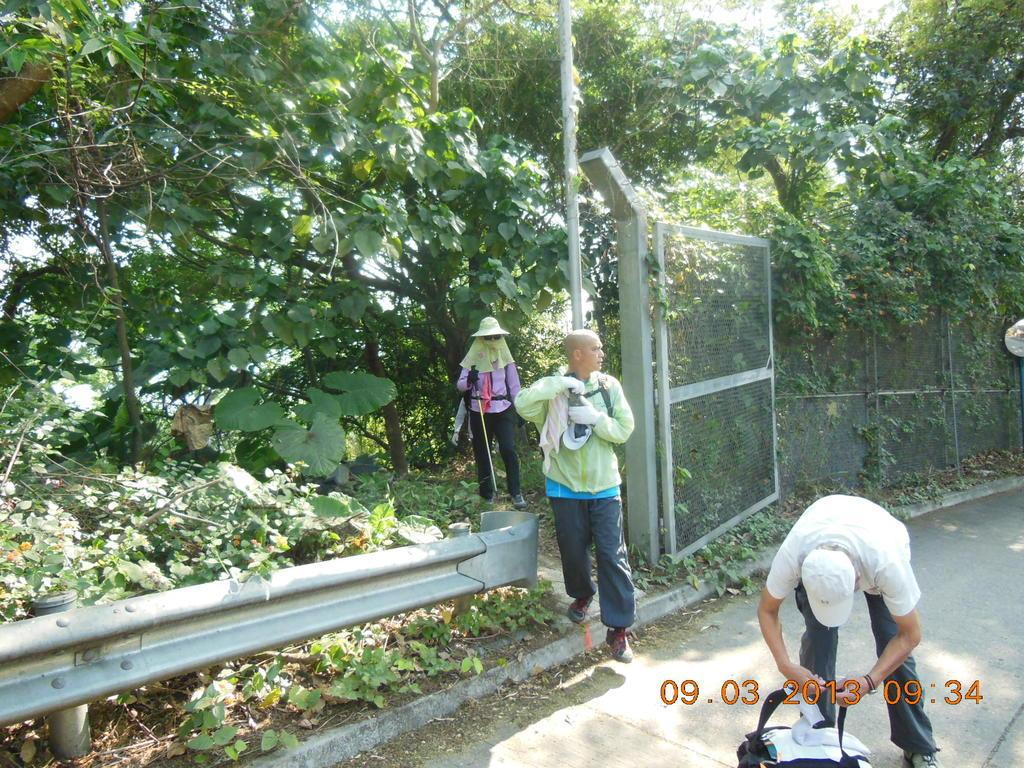What are the people in the image doing? The persons in the image are standing on the road. What type of vegetation can be seen in the image? Creepers and trees are visible in the image. What structures are present in the image to control traffic or provide safety? Barriers and fencing are present in the image. What is visible in the background of the image? The sky is visible in the image. Where is the harbor located in the image? There is no harbor present in the image. What type of brush is being used by the persons in the image? There is no brush visible in the image; the persons are simply standing on the road. 